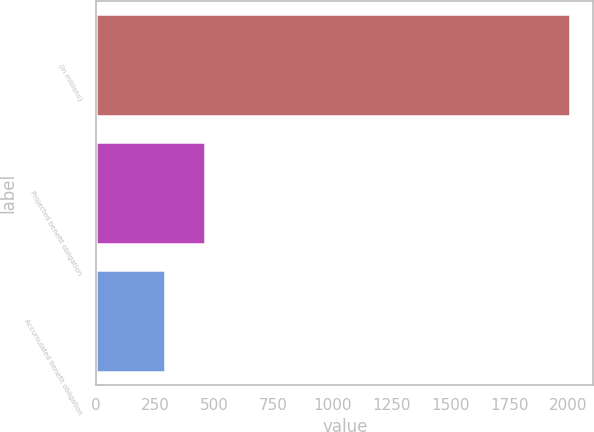Convert chart to OTSL. <chart><loc_0><loc_0><loc_500><loc_500><bar_chart><fcel>(In millions)<fcel>Projected benefit obligation<fcel>Accumulated benefit obligation<nl><fcel>2005<fcel>463.21<fcel>291.9<nl></chart> 